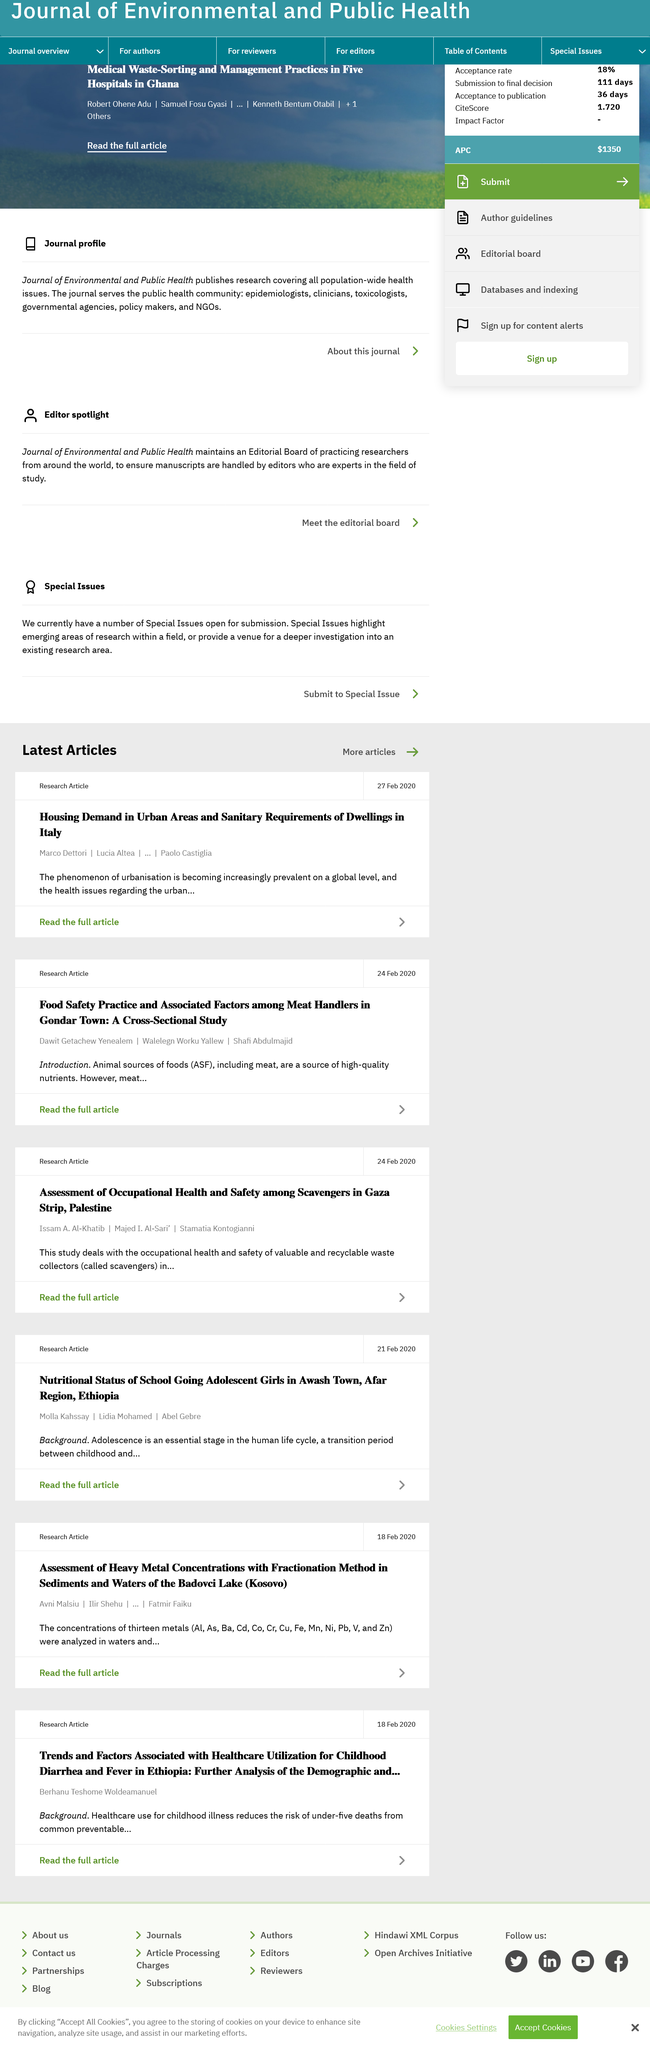Draw attention to some important aspects in this diagram. Animal sources of foods (ASF) refer to food products derived from animal origin, such as meat, poultry, eggs, and dairy products. The research article was published on February 24, 2020. The phenomenon of urbanization is becoming more prevalent on a global level. 